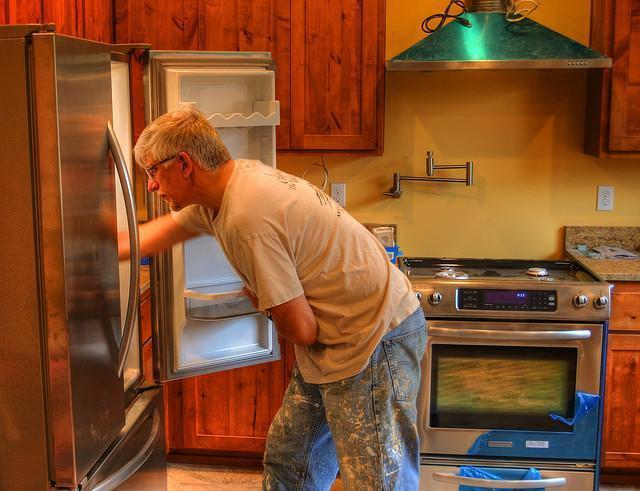Does the image validate the caption "The oven is at the right side of the person."?
Answer yes or no. Yes. 